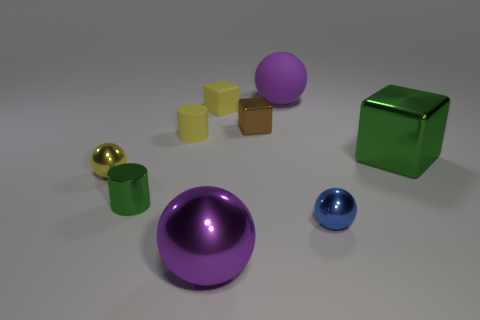Does the small cylinder in front of the large green metal thing have the same color as the metallic cube that is on the right side of the large purple matte thing?
Your answer should be very brief. Yes. Are there the same number of metallic cylinders behind the yellow rubber cube and things that are right of the purple shiny sphere?
Give a very brief answer. No. There is a purple thing behind the large thing that is in front of the green cylinder; what is its size?
Your response must be concise. Large. Are there any green matte objects that have the same size as the metallic cylinder?
Provide a succinct answer. No. The big block that is the same material as the tiny blue sphere is what color?
Make the answer very short. Green. Is the number of cubes less than the number of yellow metallic things?
Make the answer very short. No. What is the material of the object that is both right of the big matte sphere and in front of the big green thing?
Make the answer very short. Metal. There is a purple object behind the blue thing; is there a small yellow rubber object that is behind it?
Offer a terse response. No. How many small things have the same color as the tiny matte block?
Make the answer very short. 2. What is the material of the small sphere that is the same color as the matte cylinder?
Your answer should be very brief. Metal. 